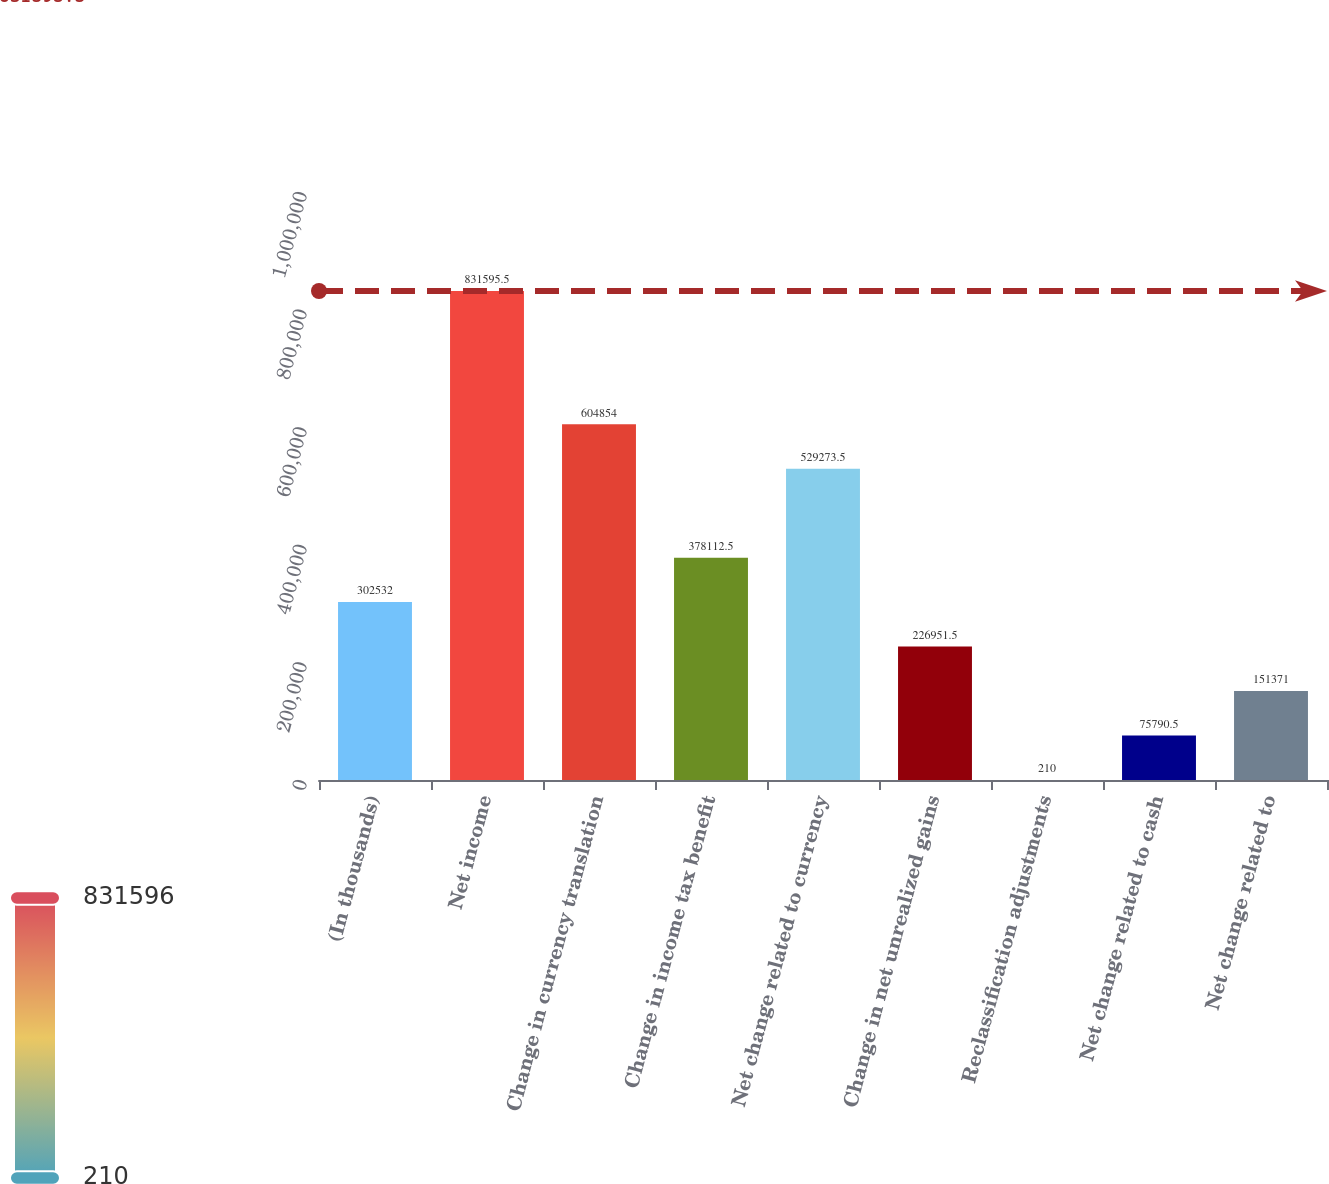Convert chart. <chart><loc_0><loc_0><loc_500><loc_500><bar_chart><fcel>(In thousands)<fcel>Net income<fcel>Change in currency translation<fcel>Change in income tax benefit<fcel>Net change related to currency<fcel>Change in net unrealized gains<fcel>Reclassification adjustments<fcel>Net change related to cash<fcel>Net change related to<nl><fcel>302532<fcel>831596<fcel>604854<fcel>378112<fcel>529274<fcel>226952<fcel>210<fcel>75790.5<fcel>151371<nl></chart> 